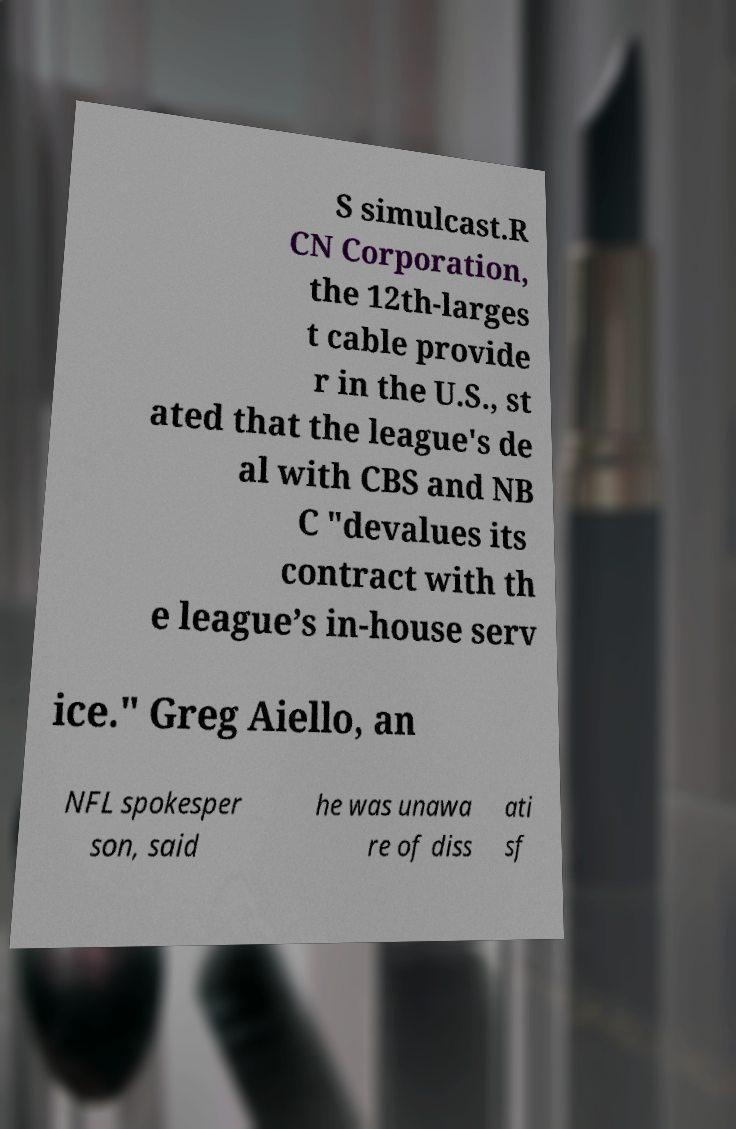Can you accurately transcribe the text from the provided image for me? S simulcast.R CN Corporation, the 12th-larges t cable provide r in the U.S., st ated that the league's de al with CBS and NB C "devalues its contract with th e league’s in-house serv ice." Greg Aiello, an NFL spokesper son, said he was unawa re of diss ati sf 